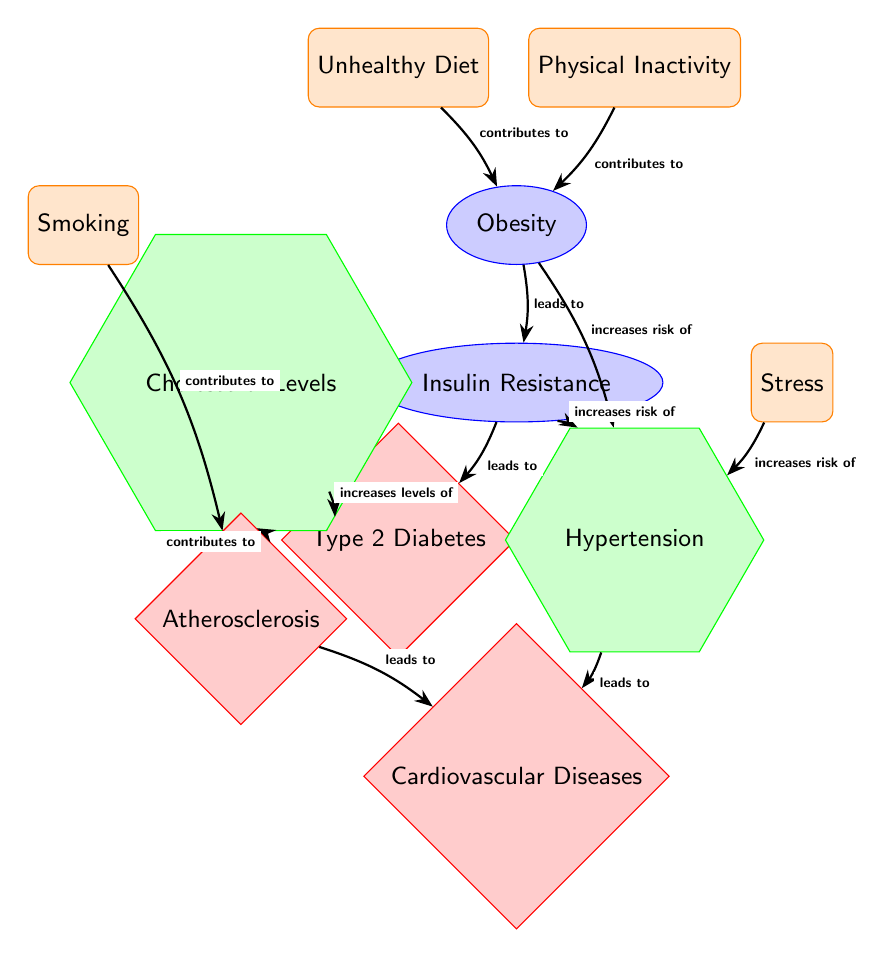What are the two lifestyle factors that contribute to obesity? The diagram indicates that "Unhealthy Diet" and "Physical Inactivity" are the two lifestyle factors that both contribute to the condition of obesity.
Answer: Unhealthy Diet, Physical Inactivity What does obesity lead to? Following the arrows in the diagram, obesity leads to "Insulin Resistance," as indicated by the connection labeled "leads to."
Answer: Insulin Resistance How many risk factors are identified in the diagram? By counting the shapes designated as risk factors, there are three risk factors shown in the diagram, which are hypertension, cholesterol levels, and the influence of stress.
Answer: 3 What condition increases the risk of hypertension? The diagram shows that both "Obesity" and "Insulin Resistance" increase the risk of hypertension, as per the connections portrayed.
Answer: Obesity, Insulin Resistance Which disease does atherosclerosis lead to? In the diagram, the arrow pointing from "Atherosclerosis" leads to "Cardiovascular Diseases," indicating the direct relationship.
Answer: Cardiovascular Diseases How does insulin resistance affect cholesterol levels? The diagram shows that "Insulin Resistance" leads to "Type 2 Diabetes," which then increases levels of "Cholesterol Levels," creating a causal pathway connecting the two.
Answer: Increases levels of What factors contribute to atherosclerosis? The diagram points out both "Cholesterol Levels" and "Smoking" as contributing factors to atherosclerosis, shown by their respective relationships to this condition.
Answer: Cholesterol Levels, Smoking What role does stress play in hypertension? The diagram indicates that "Stress" increases the risk of hypertension, shown by the arrow labeled "increases risk of" connecting these two factors.
Answer: Increases risk of What is the final disease resulting from the key conditions outlined in the diagram? The structure of the diagram culminates in "Cardiovascular Diseases" as the final disease linked through various conditions like atherosclerosis and insulin resistance.
Answer: Cardiovascular Diseases 